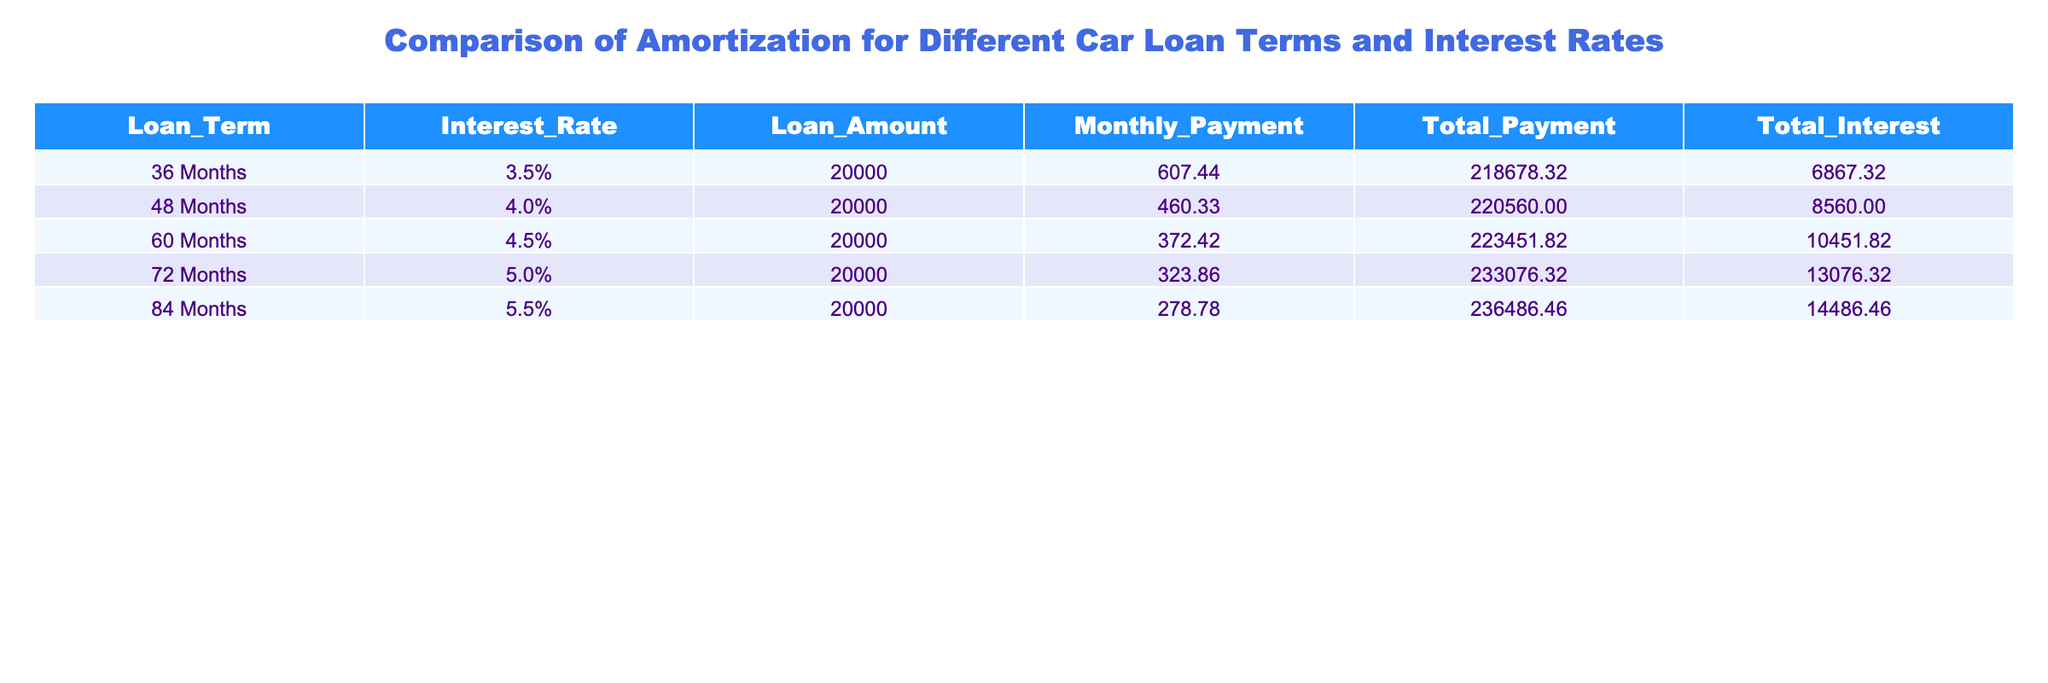What is the monthly payment for a 60-month loan at 4.5% interest? The table indicates that for a 60-month loan at 4.5% interest, the monthly payment is listed as 372.42.
Answer: 372.42 Which loan term has the highest total payment? By inspecting the total payment figures, the 84-month loan has the highest total payment at 236486.46.
Answer: 84 Months What is the total interest paid for a 48-month loan compared to a 72-month loan? The total interest for the 48-month loan is 8560.00, and for the 72-month loan, it is 13076.32. The difference is 13076.32 - 8560.00 = 4506.32.
Answer: 4506.32 Is the monthly payment for a 36-month loan less than that of a 48-month loan? The monthly payment for the 36-month loan is 607.44, while for the 48-month loan, it is 460.33. Since 607.44 is greater than 460.33, the statement is false.
Answer: No What is the average monthly payment across all loan terms listed in the table? To find the average monthly payment, sum the monthly payments: 607.44 + 460.33 + 372.42 + 323.86 + 278.78 = 2043.83. Then divide by the number of loan terms (5): 2043.83 / 5 = 408.77.
Answer: 408.77 If I want to minimize total interest paid, which loan term should I choose? The loan term with the lowest total interest is the 36-month loan, with a total interest of 6867.32. To minimize total interest, choose the 36-month loan.
Answer: 36 Months Which loan term has the least total payment? The loan term with the least total payment according to the table is the 36-month loan with a total payment of 218678.32.
Answer: 36 Months How much more total interest is paid on a 60-month loan than on a 36-month loan? The total interest for the 60-month loan is 10451.82, and for the 36-month loan, it is 6867.32. The difference is calculated as 10451.82 - 6867.32 = 3584.50.
Answer: 3584.50 